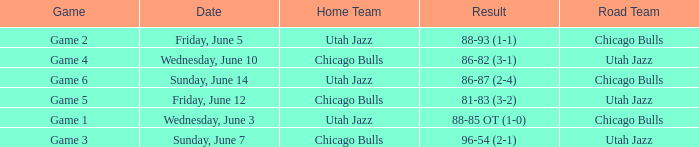Which game is associated with the score 88-85 ot (1-0)? Game 1. 